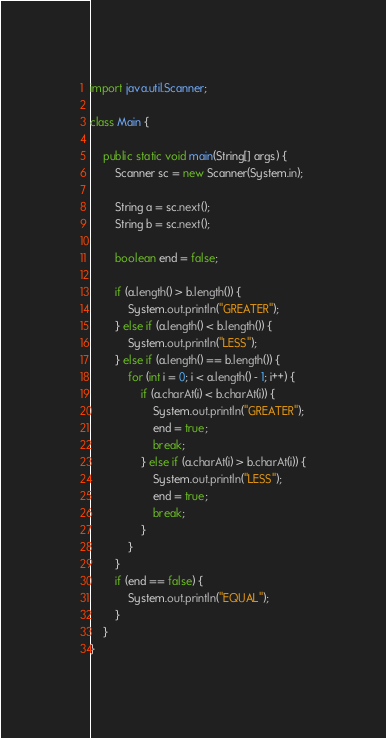Convert code to text. <code><loc_0><loc_0><loc_500><loc_500><_Java_>
import java.util.Scanner;

class Main {

    public static void main(String[] args) {
        Scanner sc = new Scanner(System.in);

        String a = sc.next();
        String b = sc.next();

        boolean end = false;

        if (a.length() > b.length()) {
            System.out.println("GREATER");
        } else if (a.length() < b.length()) {
            System.out.println("LESS");
        } else if (a.length() == b.length()) {
            for (int i = 0; i < a.length() - 1; i++) {
                if (a.charAt(i) < b.charAt(i)) {
                    System.out.println("GREATER");
                    end = true;
                    break;
                } else if (a.charAt(i) > b.charAt(i)) {
                    System.out.println("LESS");
                    end = true;
                    break;
                }
            }
        }
        if (end == false) {
            System.out.println("EQUAL");
        }
    }
}
</code> 